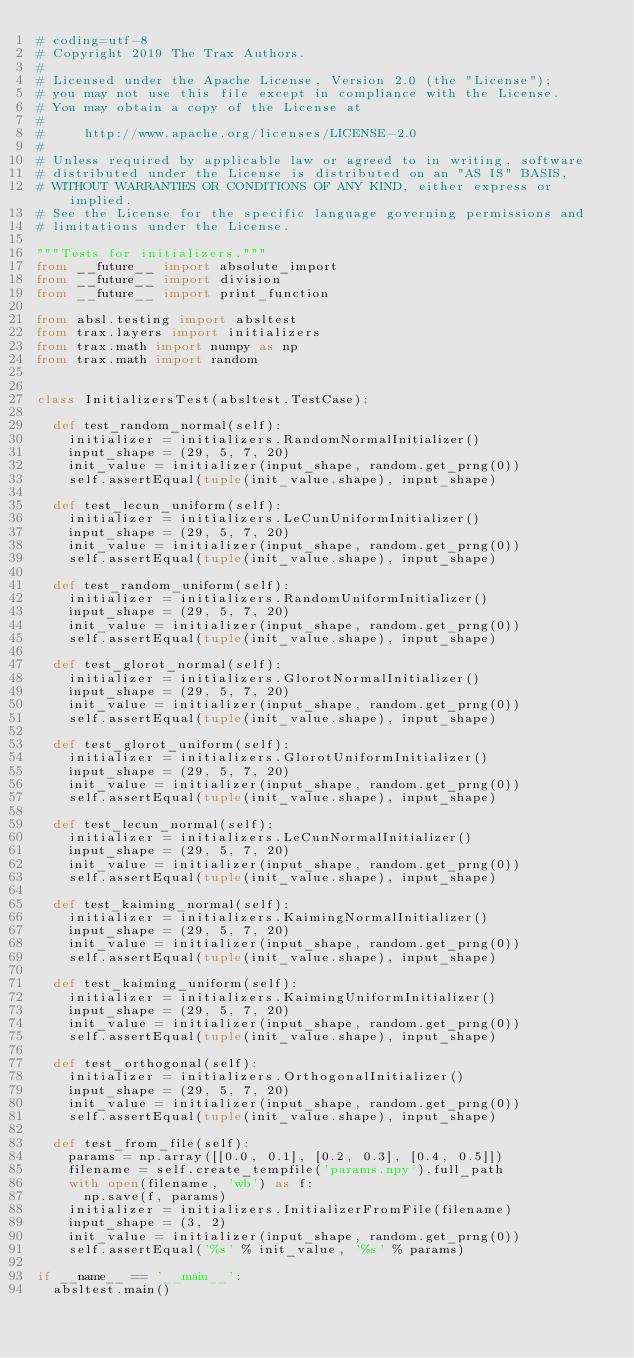<code> <loc_0><loc_0><loc_500><loc_500><_Python_># coding=utf-8
# Copyright 2019 The Trax Authors.
#
# Licensed under the Apache License, Version 2.0 (the "License");
# you may not use this file except in compliance with the License.
# You may obtain a copy of the License at
#
#     http://www.apache.org/licenses/LICENSE-2.0
#
# Unless required by applicable law or agreed to in writing, software
# distributed under the License is distributed on an "AS IS" BASIS,
# WITHOUT WARRANTIES OR CONDITIONS OF ANY KIND, either express or implied.
# See the License for the specific language governing permissions and
# limitations under the License.

"""Tests for initializers."""
from __future__ import absolute_import
from __future__ import division
from __future__ import print_function

from absl.testing import absltest
from trax.layers import initializers
from trax.math import numpy as np
from trax.math import random


class InitializersTest(absltest.TestCase):

  def test_random_normal(self):
    initializer = initializers.RandomNormalInitializer()
    input_shape = (29, 5, 7, 20)
    init_value = initializer(input_shape, random.get_prng(0))
    self.assertEqual(tuple(init_value.shape), input_shape)

  def test_lecun_uniform(self):
    initializer = initializers.LeCunUniformInitializer()
    input_shape = (29, 5, 7, 20)
    init_value = initializer(input_shape, random.get_prng(0))
    self.assertEqual(tuple(init_value.shape), input_shape)

  def test_random_uniform(self):
    initializer = initializers.RandomUniformInitializer()
    input_shape = (29, 5, 7, 20)
    init_value = initializer(input_shape, random.get_prng(0))
    self.assertEqual(tuple(init_value.shape), input_shape)

  def test_glorot_normal(self):
    initializer = initializers.GlorotNormalInitializer()
    input_shape = (29, 5, 7, 20)
    init_value = initializer(input_shape, random.get_prng(0))
    self.assertEqual(tuple(init_value.shape), input_shape)

  def test_glorot_uniform(self):
    initializer = initializers.GlorotUniformInitializer()
    input_shape = (29, 5, 7, 20)
    init_value = initializer(input_shape, random.get_prng(0))
    self.assertEqual(tuple(init_value.shape), input_shape)

  def test_lecun_normal(self):
    initializer = initializers.LeCunNormalInitializer()
    input_shape = (29, 5, 7, 20)
    init_value = initializer(input_shape, random.get_prng(0))
    self.assertEqual(tuple(init_value.shape), input_shape)

  def test_kaiming_normal(self):
    initializer = initializers.KaimingNormalInitializer()
    input_shape = (29, 5, 7, 20)
    init_value = initializer(input_shape, random.get_prng(0))
    self.assertEqual(tuple(init_value.shape), input_shape)

  def test_kaiming_uniform(self):
    initializer = initializers.KaimingUniformInitializer()
    input_shape = (29, 5, 7, 20)
    init_value = initializer(input_shape, random.get_prng(0))
    self.assertEqual(tuple(init_value.shape), input_shape)

  def test_orthogonal(self):
    initializer = initializers.OrthogonalInitializer()
    input_shape = (29, 5, 7, 20)
    init_value = initializer(input_shape, random.get_prng(0))
    self.assertEqual(tuple(init_value.shape), input_shape)

  def test_from_file(self):
    params = np.array([[0.0, 0.1], [0.2, 0.3], [0.4, 0.5]])
    filename = self.create_tempfile('params.npy').full_path
    with open(filename, 'wb') as f:
      np.save(f, params)
    initializer = initializers.InitializerFromFile(filename)
    input_shape = (3, 2)
    init_value = initializer(input_shape, random.get_prng(0))
    self.assertEqual('%s' % init_value, '%s' % params)

if __name__ == '__main__':
  absltest.main()
</code> 